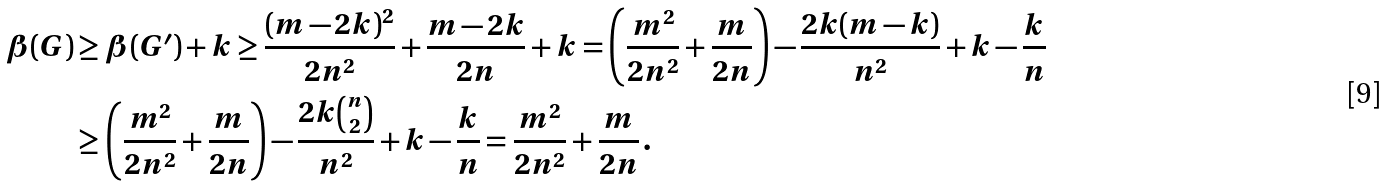<formula> <loc_0><loc_0><loc_500><loc_500>\beta ( G ) & \geq \beta ( G ^ { \prime } ) + k \geq \frac { ( m - 2 k ) ^ { 2 } } { 2 n ^ { 2 } } + \frac { m - 2 k } { 2 n } + k = \left ( \frac { m ^ { 2 } } { 2 n ^ { 2 } } + \frac { m } { 2 n } \right ) - \frac { 2 k ( m - k ) } { n ^ { 2 } } + k - \frac { k } { n } \\ & \geq \left ( \frac { m ^ { 2 } } { 2 n ^ { 2 } } + \frac { m } { 2 n } \right ) - \frac { 2 k \binom { n } { 2 } } { n ^ { 2 } } + k - \frac { k } { n } = \frac { m ^ { 2 } } { 2 n ^ { 2 } } + \frac { m } { 2 n } \, .</formula> 